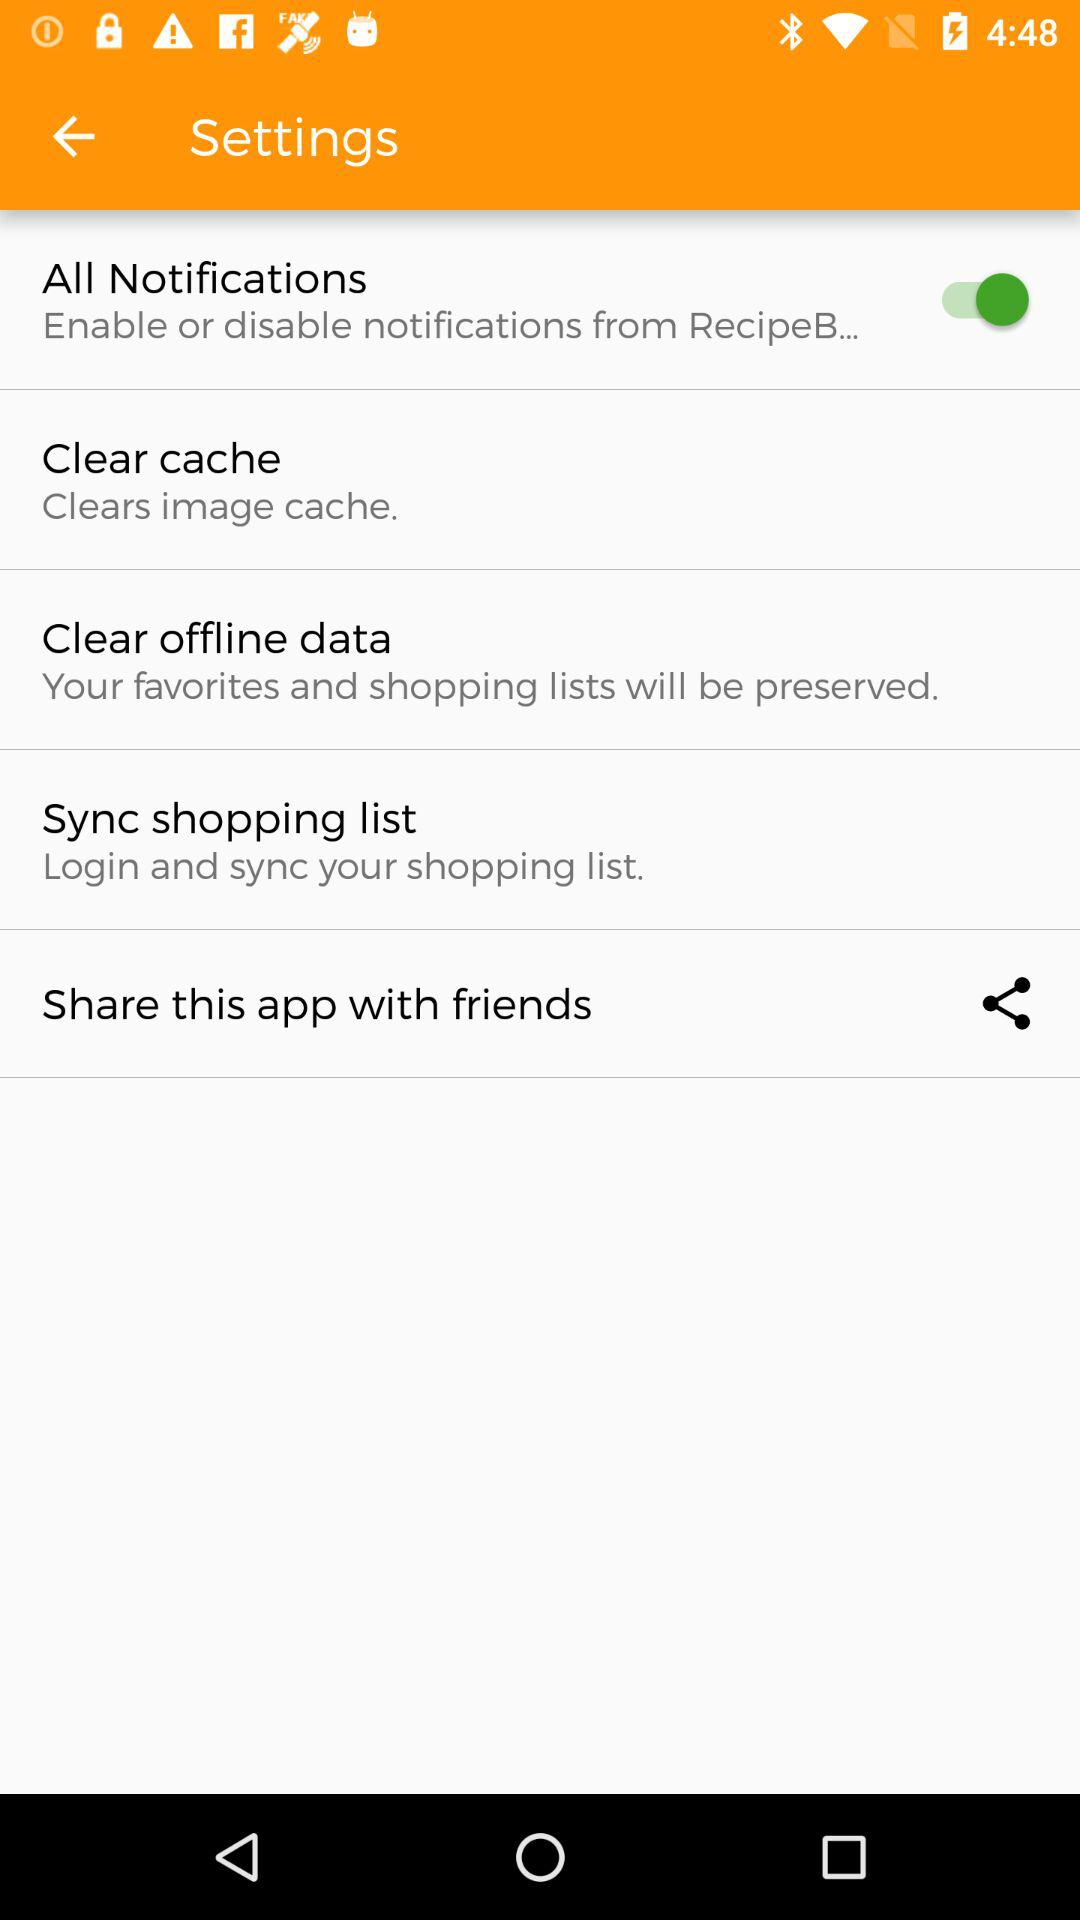How many items are there in the settings menu that do not have a switch?
Answer the question using a single word or phrase. 3 